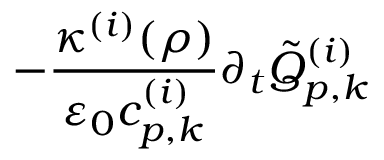<formula> <loc_0><loc_0><loc_500><loc_500>- \frac { \kappa ^ { ( i ) } ( \rho ) } { \varepsilon _ { 0 } c _ { p , k } ^ { ( i ) } } \partial _ { t } \tilde { Q } _ { p , k } ^ { ( i ) }</formula> 